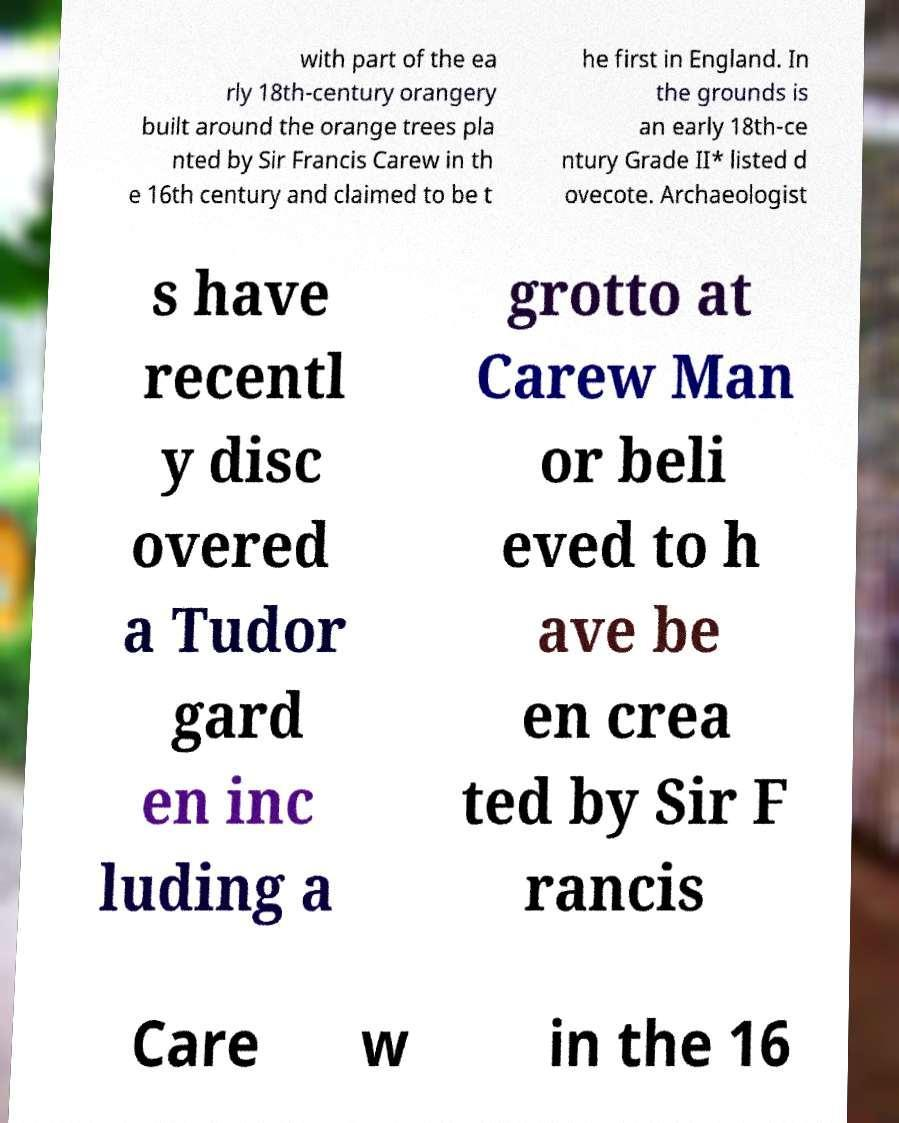Can you read and provide the text displayed in the image?This photo seems to have some interesting text. Can you extract and type it out for me? with part of the ea rly 18th-century orangery built around the orange trees pla nted by Sir Francis Carew in th e 16th century and claimed to be t he first in England. In the grounds is an early 18th-ce ntury Grade II* listed d ovecote. Archaeologist s have recentl y disc overed a Tudor gard en inc luding a grotto at Carew Man or beli eved to h ave be en crea ted by Sir F rancis Care w in the 16 